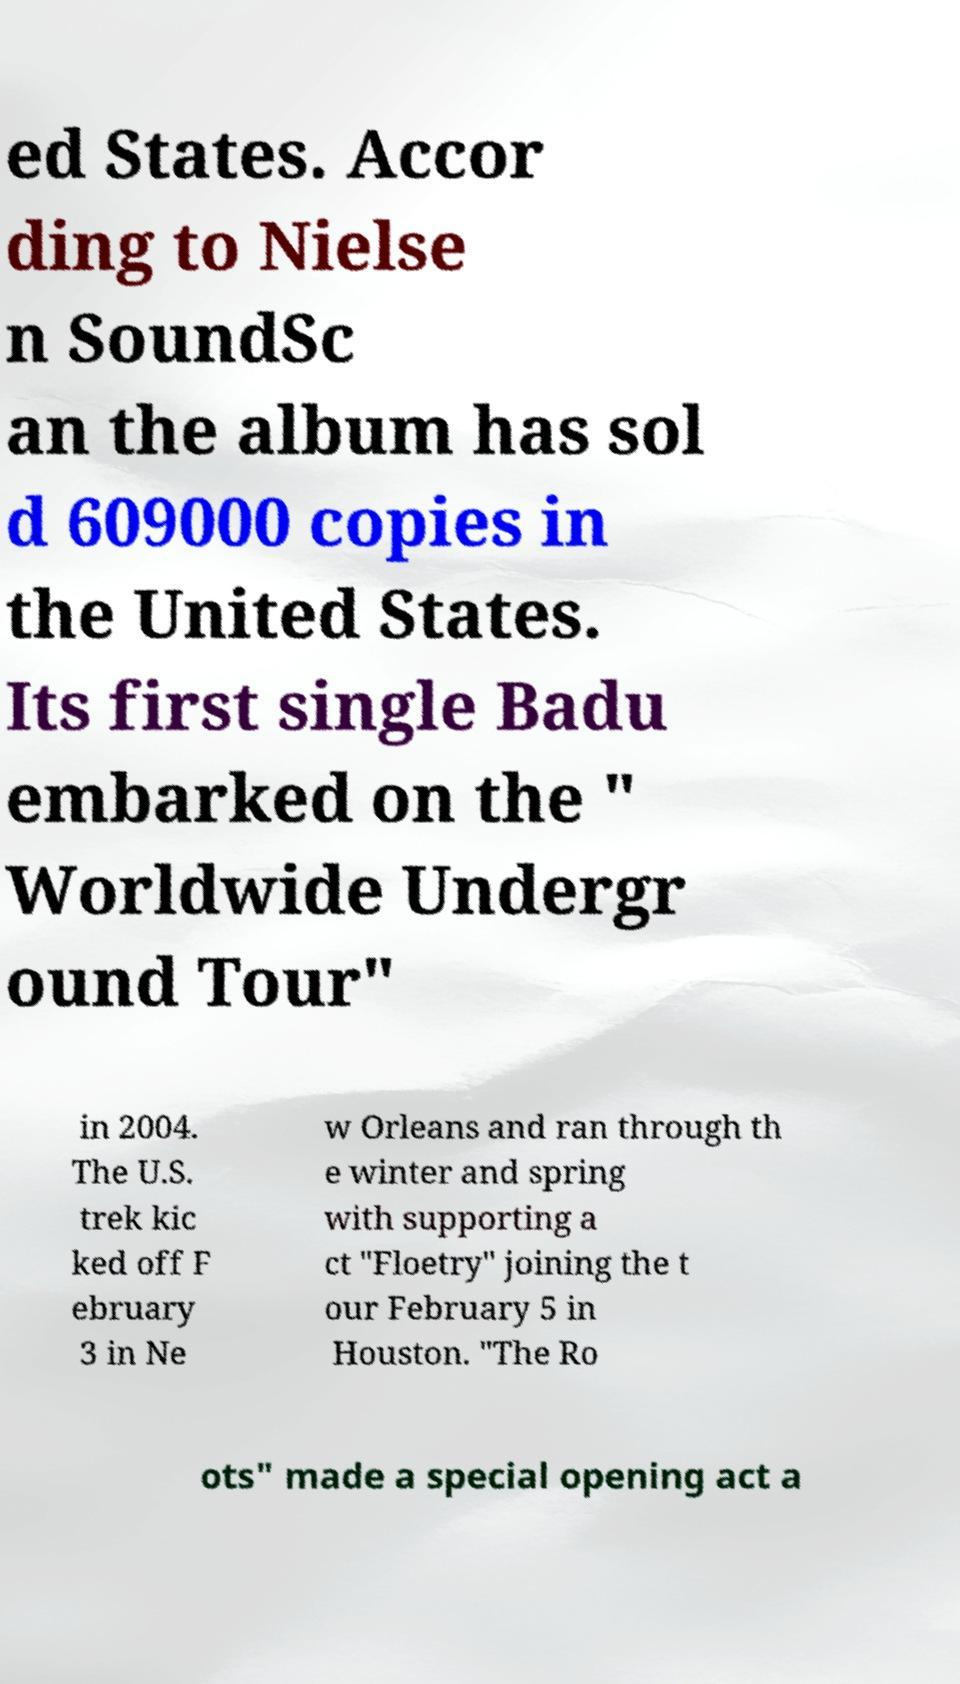Can you read and provide the text displayed in the image?This photo seems to have some interesting text. Can you extract and type it out for me? ed States. Accor ding to Nielse n SoundSc an the album has sol d 609000 copies in the United States. Its first single Badu embarked on the " Worldwide Undergr ound Tour" in 2004. The U.S. trek kic ked off F ebruary 3 in Ne w Orleans and ran through th e winter and spring with supporting a ct "Floetry" joining the t our February 5 in Houston. "The Ro ots" made a special opening act a 